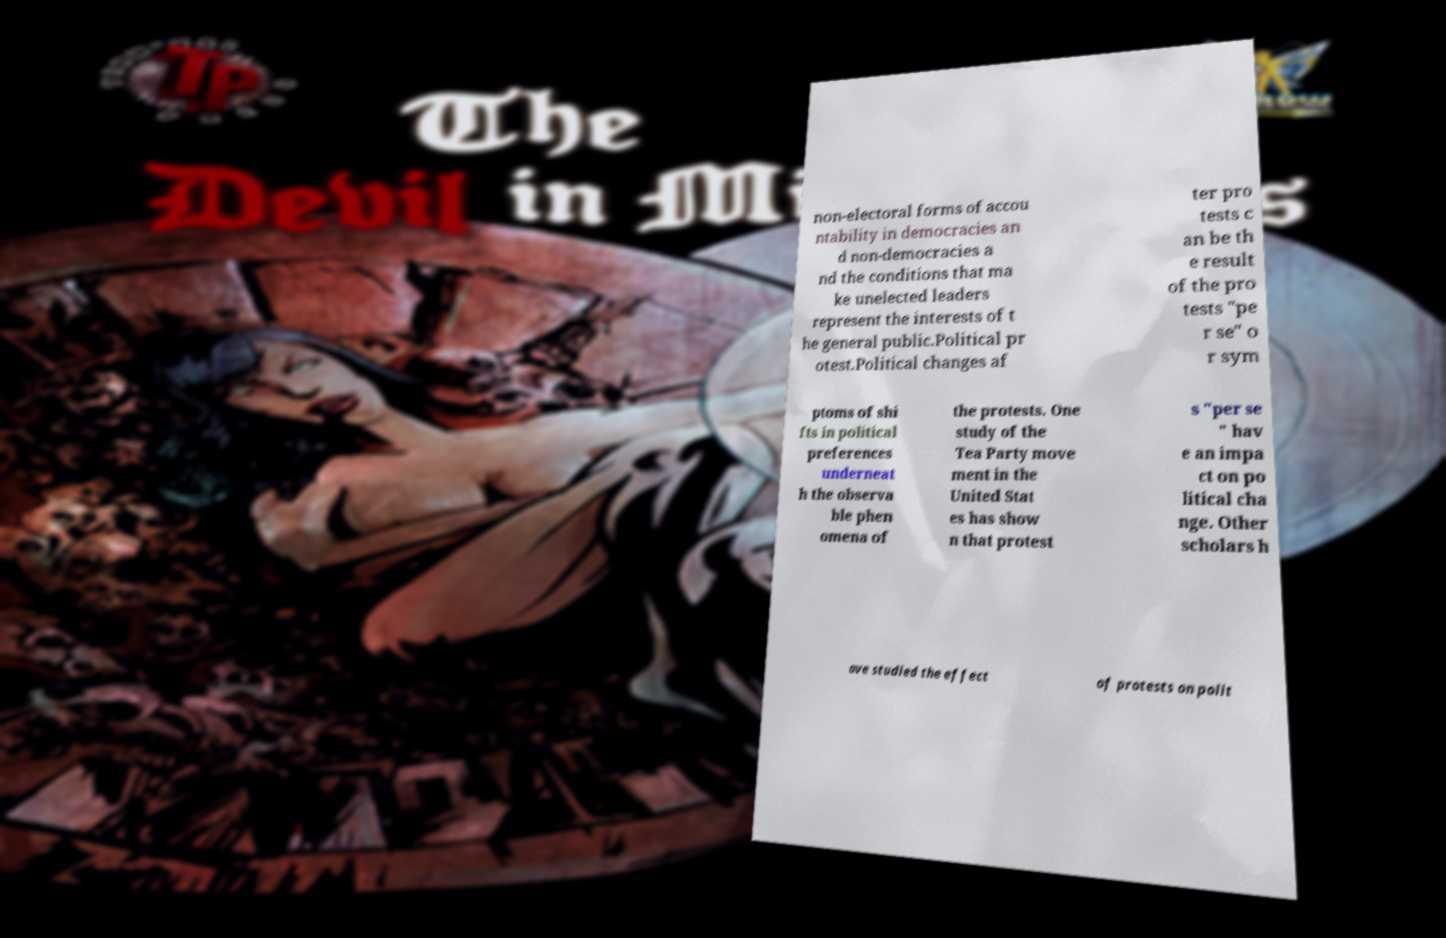Please identify and transcribe the text found in this image. non-electoral forms of accou ntability in democracies an d non-democracies a nd the conditions that ma ke unelected leaders represent the interests of t he general public.Political pr otest.Political changes af ter pro tests c an be th e result of the pro tests "pe r se" o r sym ptoms of shi fts in political preferences underneat h the observa ble phen omena of the protests. One study of the Tea Party move ment in the United Stat es has show n that protest s "per se " hav e an impa ct on po litical cha nge. Other scholars h ave studied the effect of protests on polit 